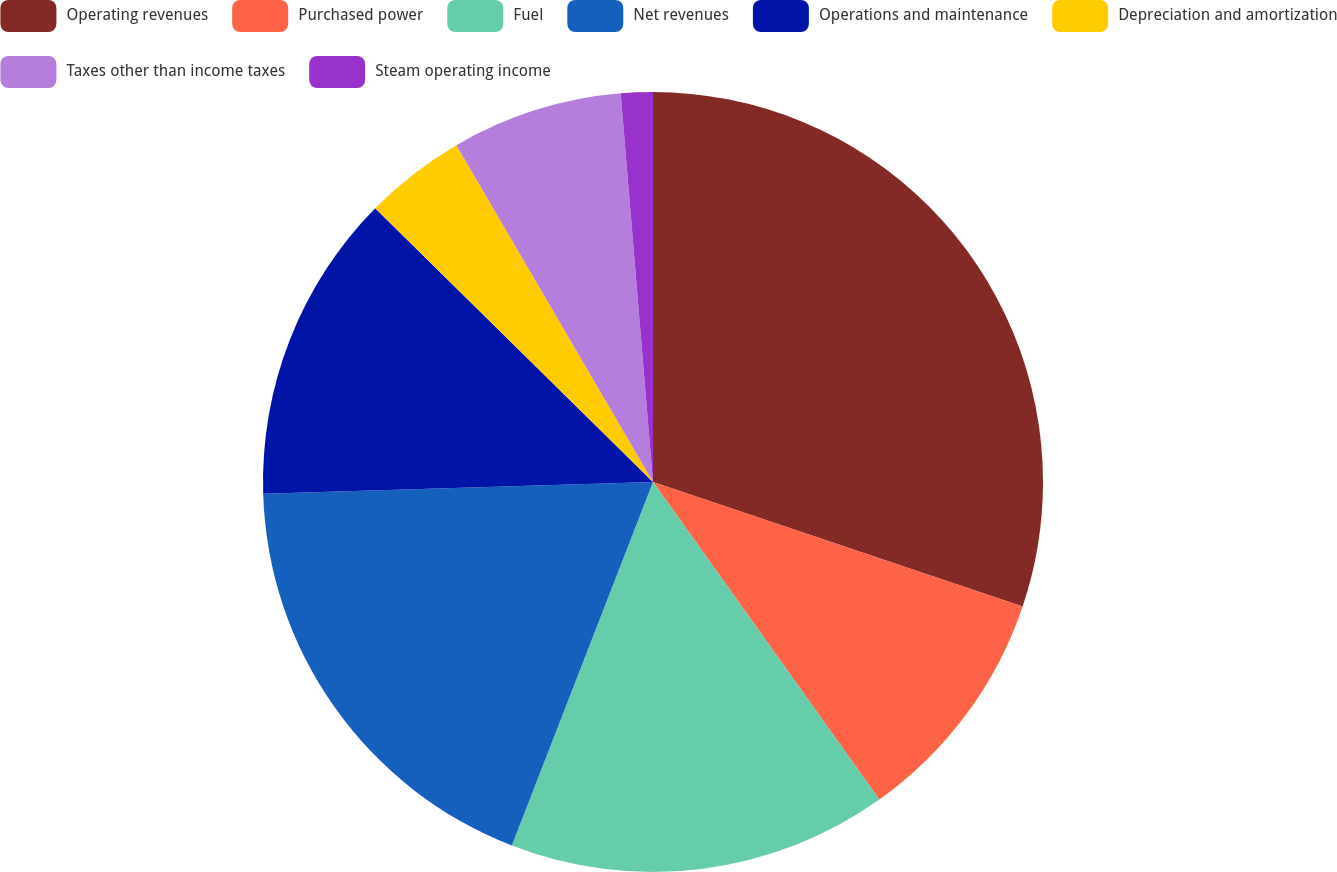Convert chart to OTSL. <chart><loc_0><loc_0><loc_500><loc_500><pie_chart><fcel>Operating revenues<fcel>Purchased power<fcel>Fuel<fcel>Net revenues<fcel>Operations and maintenance<fcel>Depreciation and amortization<fcel>Taxes other than income taxes<fcel>Steam operating income<nl><fcel>30.17%<fcel>9.98%<fcel>15.75%<fcel>18.63%<fcel>12.86%<fcel>4.21%<fcel>7.09%<fcel>1.32%<nl></chart> 